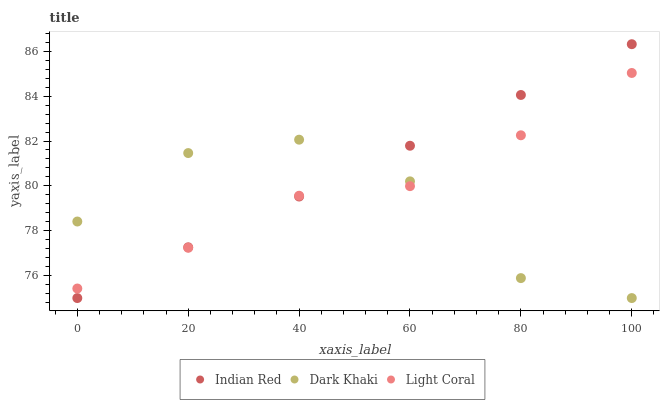Does Dark Khaki have the minimum area under the curve?
Answer yes or no. Yes. Does Indian Red have the maximum area under the curve?
Answer yes or no. Yes. Does Light Coral have the minimum area under the curve?
Answer yes or no. No. Does Light Coral have the maximum area under the curve?
Answer yes or no. No. Is Indian Red the smoothest?
Answer yes or no. Yes. Is Dark Khaki the roughest?
Answer yes or no. Yes. Is Light Coral the smoothest?
Answer yes or no. No. Is Light Coral the roughest?
Answer yes or no. No. Does Dark Khaki have the lowest value?
Answer yes or no. Yes. Does Light Coral have the lowest value?
Answer yes or no. No. Does Indian Red have the highest value?
Answer yes or no. Yes. Does Light Coral have the highest value?
Answer yes or no. No. Does Dark Khaki intersect Light Coral?
Answer yes or no. Yes. Is Dark Khaki less than Light Coral?
Answer yes or no. No. Is Dark Khaki greater than Light Coral?
Answer yes or no. No. 